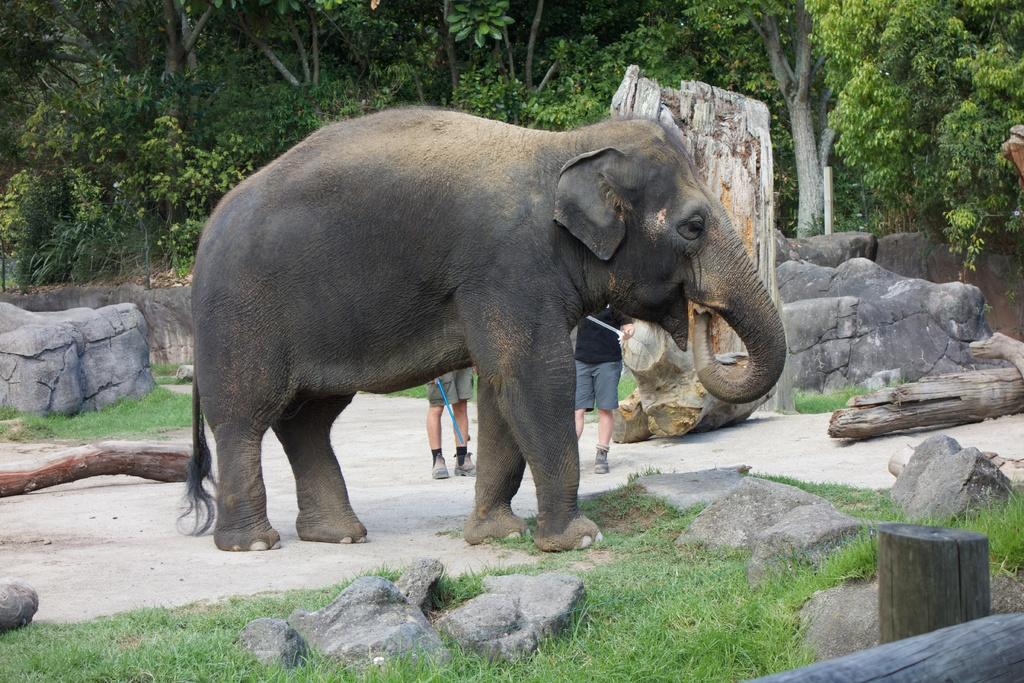What animal can be seen in the image? There is an elephant in the image. What is the elephant standing between? The elephant is standing between rocks and logs. Are there any people in the image? Yes, there are two men behind the elephant. What types of natural elements are present in the image? There are rocks, logs, trees, and grass in the image. What type of harbor can be seen in the image? There is no harbor present in the image; it features an elephant standing between rocks and logs, with trees and grass around. 